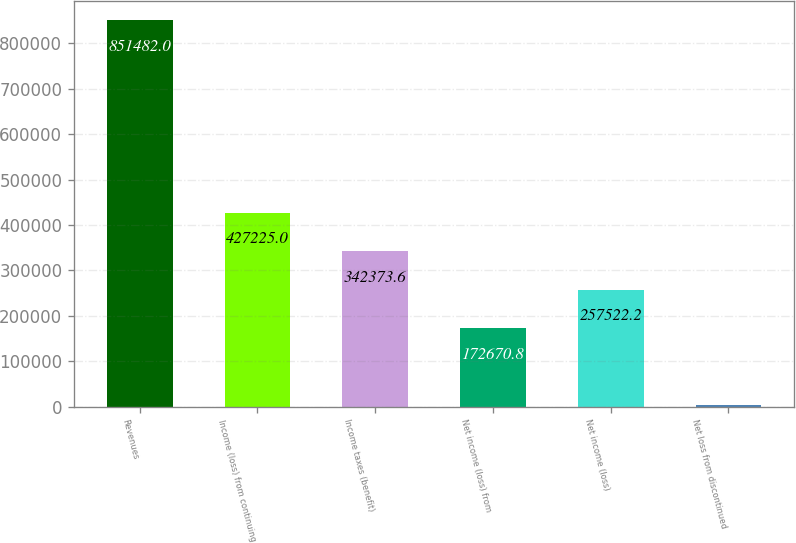Convert chart. <chart><loc_0><loc_0><loc_500><loc_500><bar_chart><fcel>Revenues<fcel>Income (loss) from continuing<fcel>Income taxes (benefit)<fcel>Net income (loss) from<fcel>Net income (loss)<fcel>Net loss from discontinued<nl><fcel>851482<fcel>427225<fcel>342374<fcel>172671<fcel>257522<fcel>2968<nl></chart> 